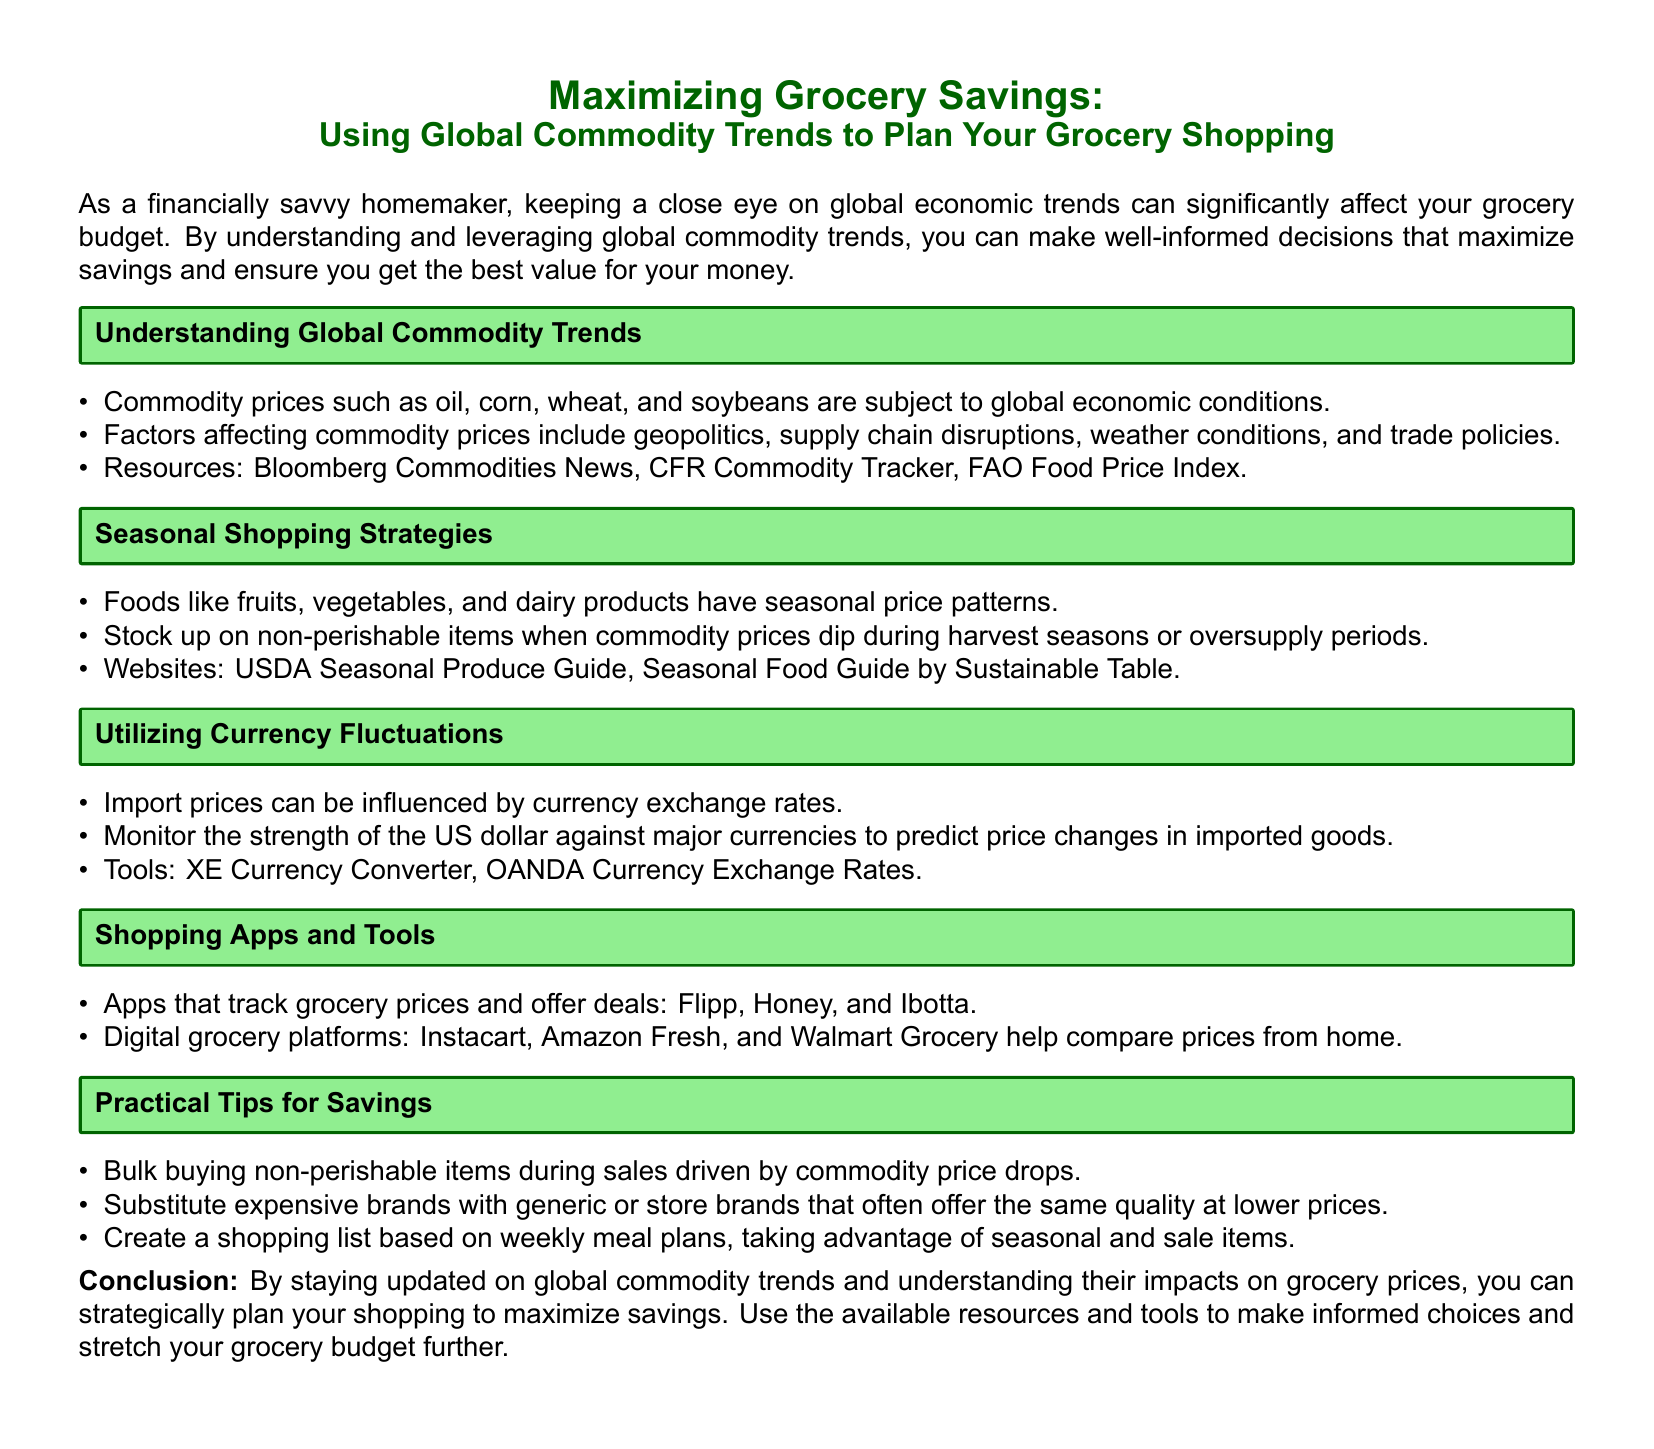What are commodities? Commodities are raw materials or primary agricultural products that can be bought and sold, such as oil, corn, wheat, and soybeans.
Answer: Raw materials What should you use to track grocery prices? The document lists apps for tracking grocery prices and deals, such as Flipp, Honey, and Ibotta.
Answer: Flipp, Honey, and Ibotta What influences import prices? The document states that import prices can be influenced by currency exchange rates.
Answer: Currency exchange rates What should you stock up on during harvest seasons? The document suggests stocking up on non-perishable items when commodity prices dip during these seasons.
Answer: Non-perishable items What is the purpose of creating a shopping list? Creating a shopping list is to base it on weekly meal plans, taking advantage of seasonal and sale items.
Answer: Maximize savings What is a key factor affecting commodity prices? The document lists various factors affecting commodity prices, one being geopolitics.
Answer: Geopolitics What is a resource for seasonal produce? The USDA Seasonal Produce Guide is mentioned as a resource.
Answer: USDA Seasonal Produce Guide Which digital platforms help compare grocery prices? The document mentions digital grocery platforms like Instacart, Amazon Fresh, and Walmart Grocery.
Answer: Instacart, Amazon Fresh, and Walmart Grocery 